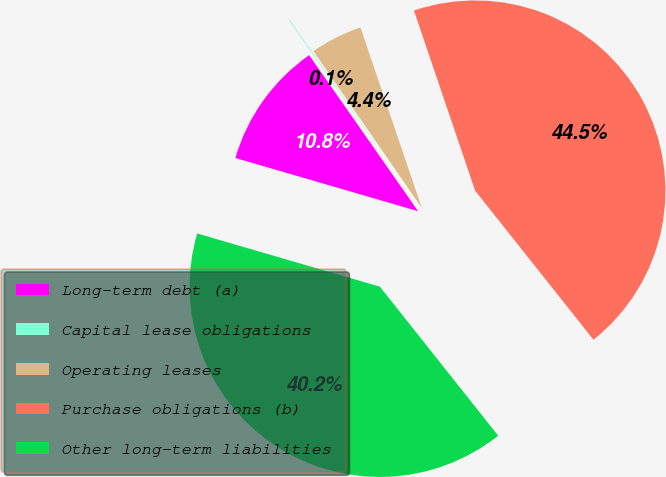<chart> <loc_0><loc_0><loc_500><loc_500><pie_chart><fcel>Long-term debt (a)<fcel>Capital lease obligations<fcel>Operating leases<fcel>Purchase obligations (b)<fcel>Other long-term liabilities<nl><fcel>10.79%<fcel>0.07%<fcel>4.42%<fcel>44.53%<fcel>40.19%<nl></chart> 